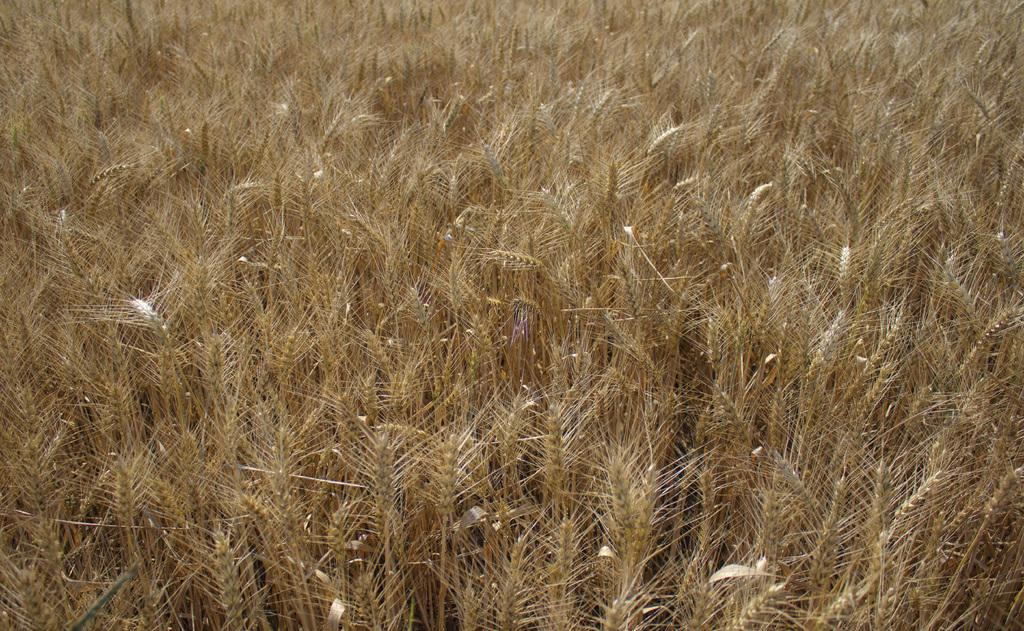What type of vegetation is present in the image? There is dry grass in the image. How many sisters are playing with the deer in the image? There are no sisters or deer present in the image; it only features dry grass. 